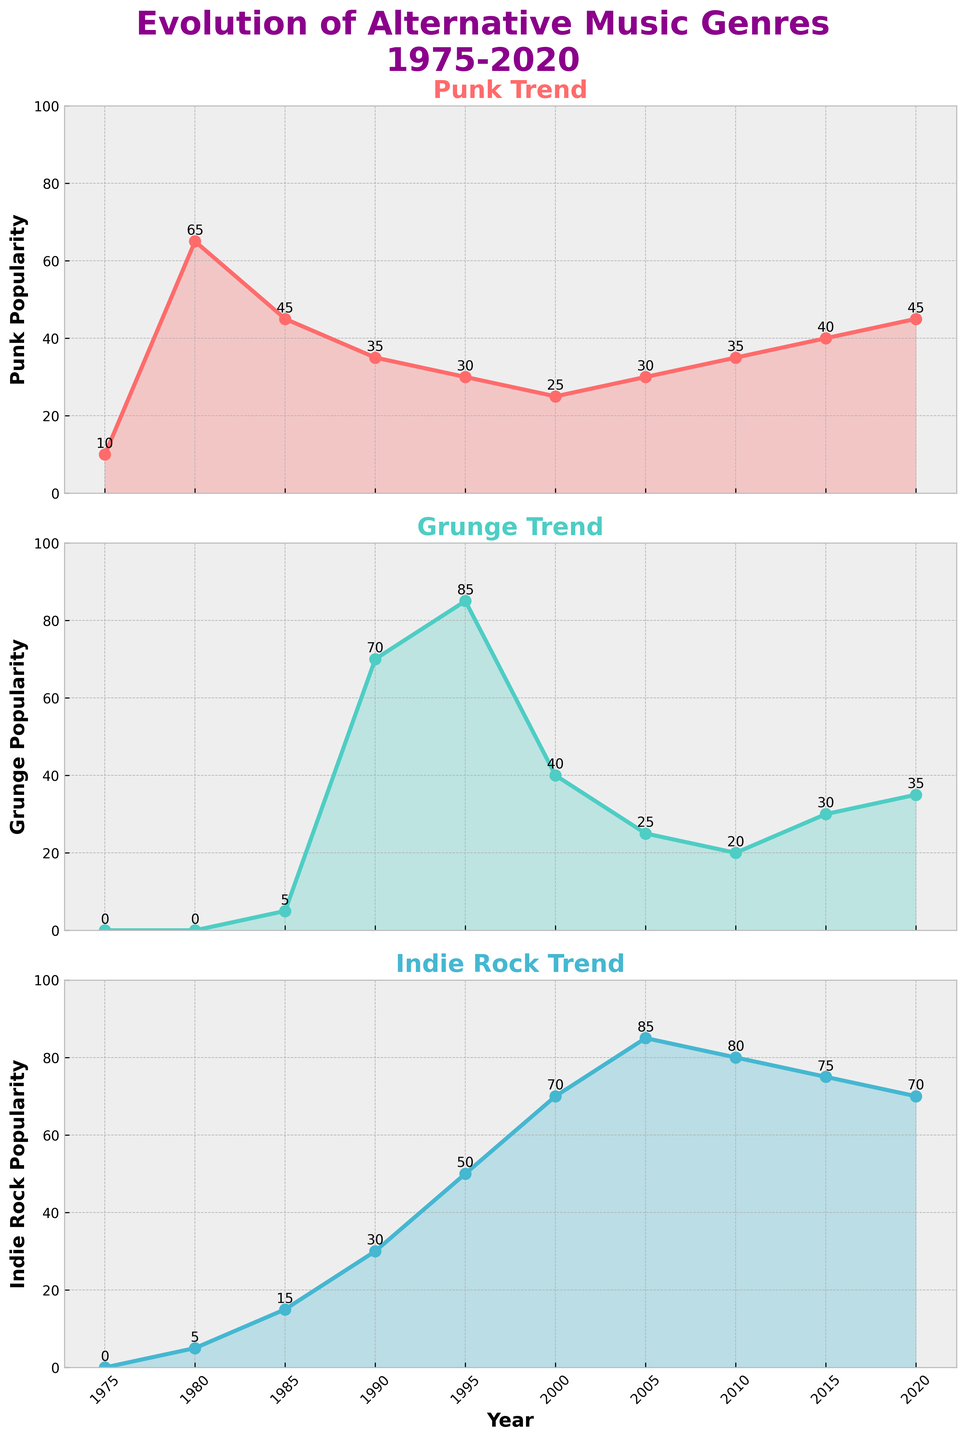Which genre had the highest popularity in 1990? To find which genre had the highest popularity in 1990, look at the vertical position of the data points for each genre in that year. Grunge is at 70, which is higher than Punk at 35 and Indie Rock at 30.
Answer: Grunge What is the main trend in popularity for Indie Rock from 1975 to 2020? Observe the overall pattern of the Indie Rock subplot. The popularity starts at 0, increases gradually, peaks around 2005, and then slightly decreases.
Answer: Increasing trend peaking around 2005 How many years did Punk remain equally popular in the provided timeframe? Check for years where the Punk data points remain the same. In this case, the popularity of Punk is 30 in both 2000 and 2005.
Answer: 2 years Which genre shows the most volatile changes in popularity? Compare the amplitude of fluctuations for all three genres. Grunge shows a significant rise and fall, indicating high volatility.
Answer: Grunge In which year was the popularity of Grunge at its highest? Look for the highest data point on the Grunge subplot. The highest value is 85, which occurs in 1995.
Answer: 1995 What is the difference in popularity between Punk and Indie Rock in 1985? Look at the values for Punk (45) and Indie Rock (15) in 1985. Calculate the difference as 45 - 15.
Answer: 30 Which genre had the least popularity in 1975? Look at the values for all three genres in 1975. Punk is at 10, while Grunge and Indie Rock are both at 0.
Answer: Grunge and Indie Rock How does the popularity of Indie Rock in 2010 compare to Punk in the same year? Find the values for Indie Rock (80) and Punk (35) in 2010. Indie Rock has higher popularity than Punk.
Answer: Indie Rock is more popular What is the average popularity of Punk from 1975 to 2020? Sum the Punk values from 1975 to 2020 and divide by the number of years: (10+65+45+35+30+25+30+35+40+45)/10 = 36
Answer: 36 During which decade did Indie Rock see the most significant rise in popularity? Assess the change in Indie Rock's popularity across each decade. The rise from 1990 (30) to 2000 (70) is the most significant.
Answer: 1990s 